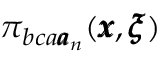Convert formula to latex. <formula><loc_0><loc_0><loc_500><loc_500>\pi _ { b c a { \pm b a } _ { n } } ( { \pm b x } , { \pm b \xi } )</formula> 